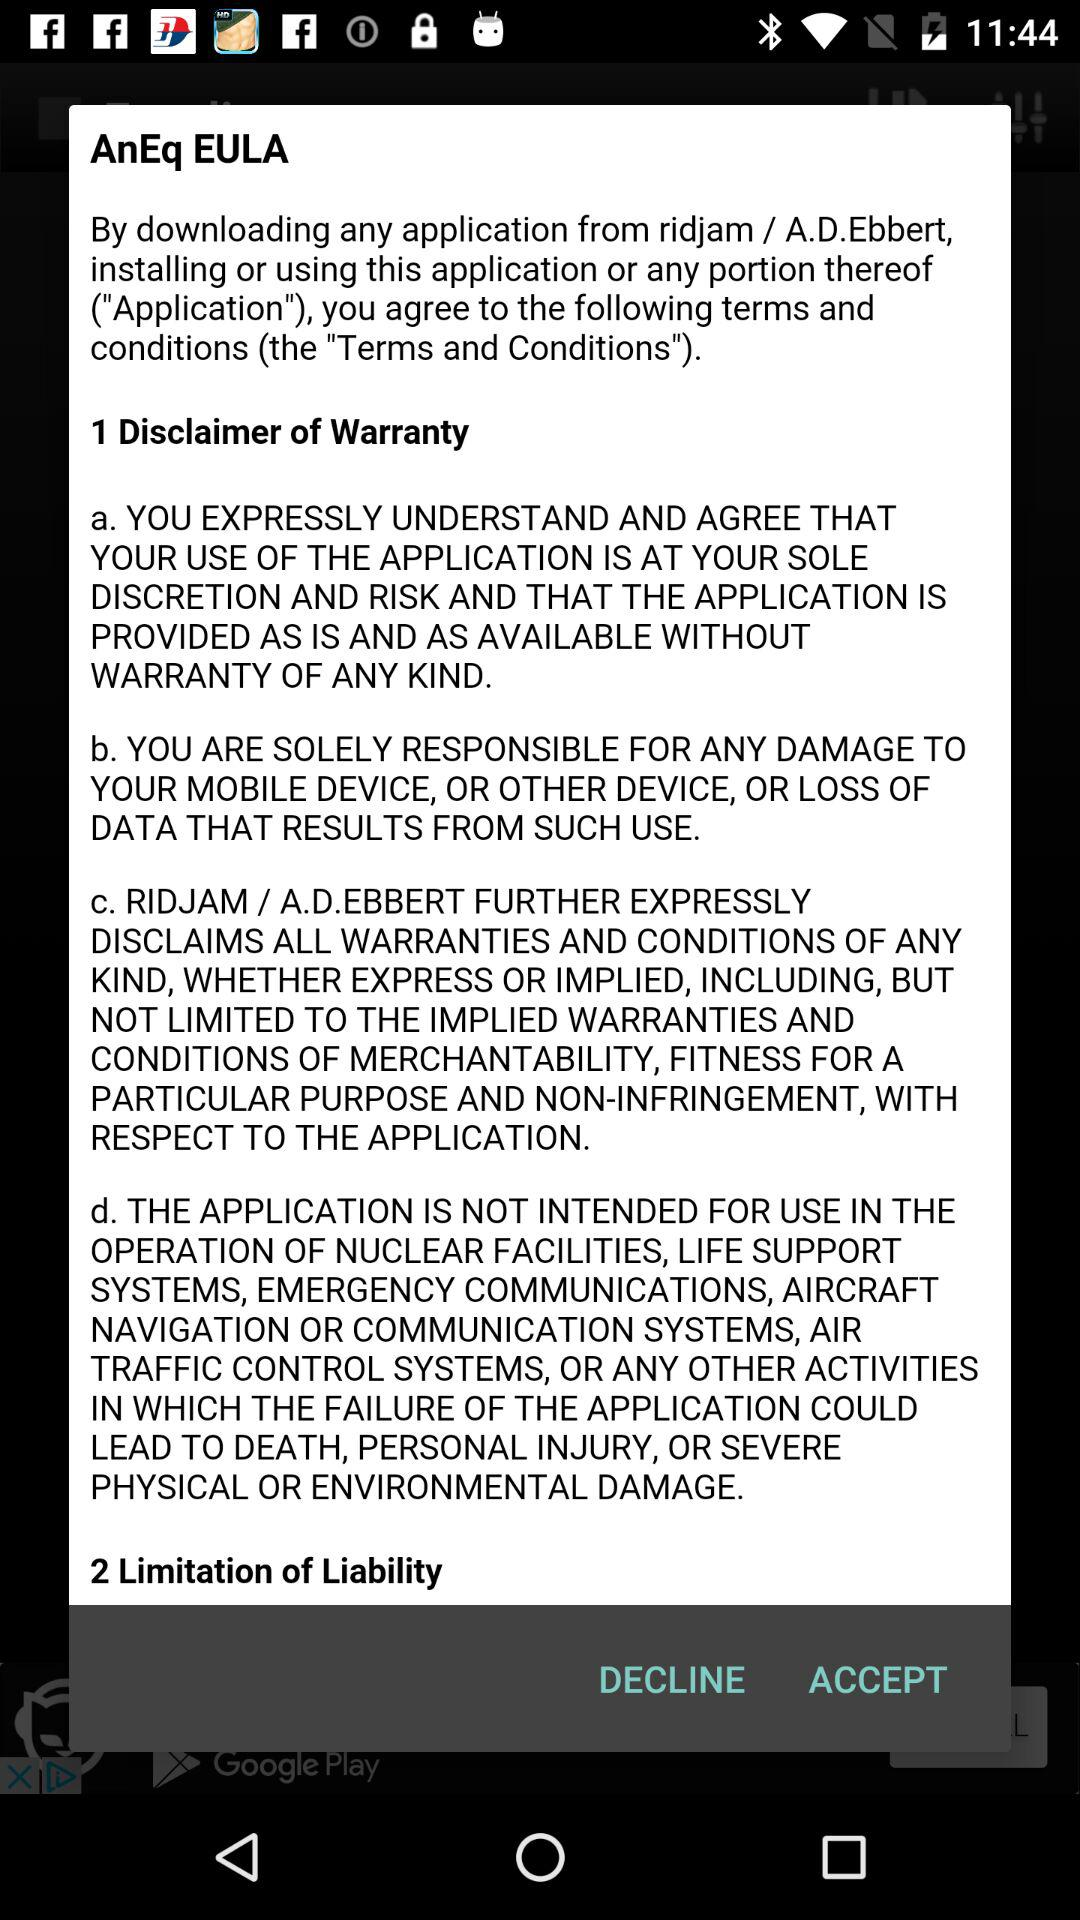How many sections do the terms of service have?
Answer the question using a single word or phrase. 2 